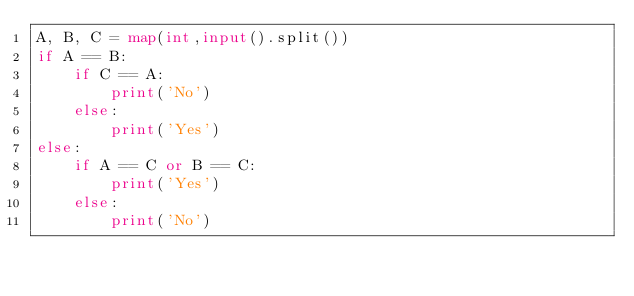Convert code to text. <code><loc_0><loc_0><loc_500><loc_500><_Python_>A, B, C = map(int,input().split())
if A == B:
    if C == A:
        print('No')
    else:
        print('Yes')
else:
    if A == C or B == C:
        print('Yes')
    else:
        print('No')</code> 